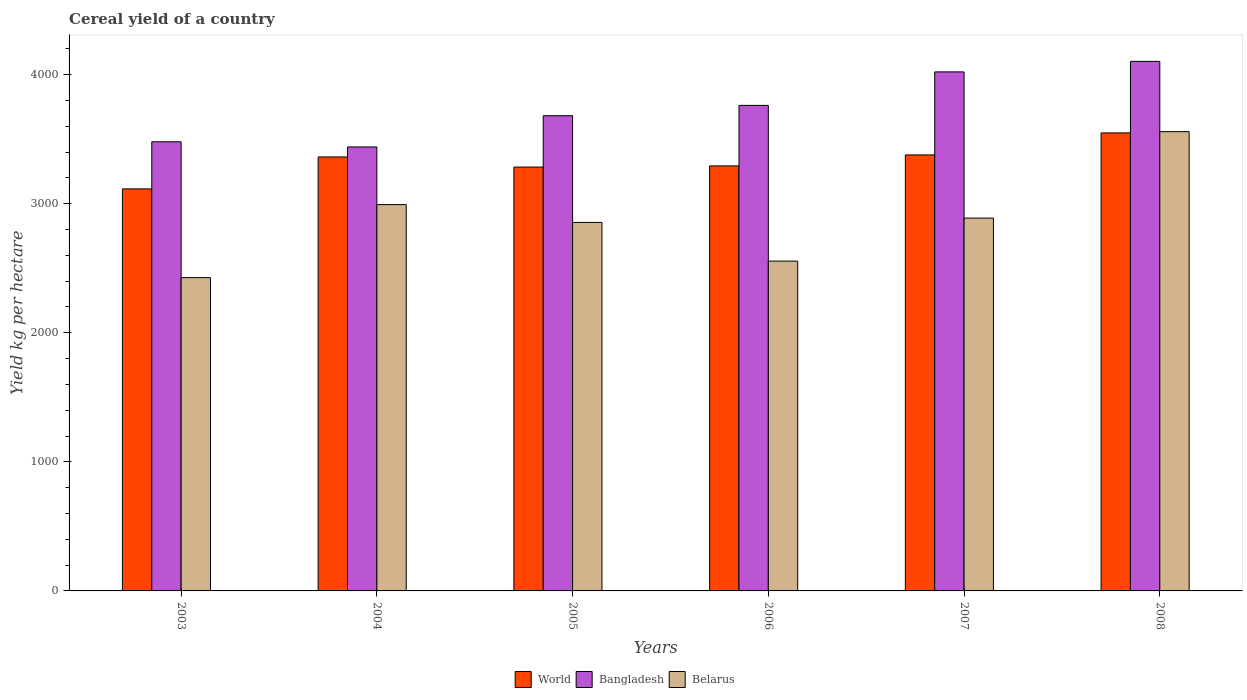How many different coloured bars are there?
Provide a short and direct response. 3. How many groups of bars are there?
Ensure brevity in your answer.  6. Are the number of bars per tick equal to the number of legend labels?
Your answer should be compact. Yes. How many bars are there on the 2nd tick from the left?
Make the answer very short. 3. How many bars are there on the 4th tick from the right?
Provide a short and direct response. 3. In how many cases, is the number of bars for a given year not equal to the number of legend labels?
Your answer should be very brief. 0. What is the total cereal yield in Bangladesh in 2006?
Your answer should be very brief. 3761.37. Across all years, what is the maximum total cereal yield in World?
Make the answer very short. 3548.21. Across all years, what is the minimum total cereal yield in Bangladesh?
Ensure brevity in your answer.  3439.43. In which year was the total cereal yield in Bangladesh minimum?
Keep it short and to the point. 2004. What is the total total cereal yield in Belarus in the graph?
Provide a succinct answer. 1.73e+04. What is the difference between the total cereal yield in Belarus in 2005 and that in 2006?
Provide a short and direct response. 299.7. What is the difference between the total cereal yield in Bangladesh in 2007 and the total cereal yield in World in 2006?
Provide a short and direct response. 728.34. What is the average total cereal yield in Belarus per year?
Make the answer very short. 2879.32. In the year 2005, what is the difference between the total cereal yield in Bangladesh and total cereal yield in World?
Provide a succinct answer. 398.08. In how many years, is the total cereal yield in Belarus greater than 2600 kg per hectare?
Provide a short and direct response. 4. What is the ratio of the total cereal yield in Bangladesh in 2003 to that in 2005?
Make the answer very short. 0.95. What is the difference between the highest and the second highest total cereal yield in Belarus?
Provide a succinct answer. 565.25. What is the difference between the highest and the lowest total cereal yield in Bangladesh?
Your response must be concise. 663.11. What does the 3rd bar from the left in 2005 represents?
Offer a terse response. Belarus. What does the 1st bar from the right in 2003 represents?
Make the answer very short. Belarus. Are all the bars in the graph horizontal?
Your response must be concise. No. How many years are there in the graph?
Ensure brevity in your answer.  6. What is the difference between two consecutive major ticks on the Y-axis?
Your answer should be very brief. 1000. Does the graph contain any zero values?
Give a very brief answer. No. Where does the legend appear in the graph?
Provide a succinct answer. Bottom center. How many legend labels are there?
Your answer should be very brief. 3. What is the title of the graph?
Keep it short and to the point. Cereal yield of a country. Does "French Polynesia" appear as one of the legend labels in the graph?
Provide a succinct answer. No. What is the label or title of the Y-axis?
Your answer should be very brief. Yield kg per hectare. What is the Yield kg per hectare in World in 2003?
Your response must be concise. 3114.57. What is the Yield kg per hectare in Bangladesh in 2003?
Ensure brevity in your answer.  3479.32. What is the Yield kg per hectare in Belarus in 2003?
Ensure brevity in your answer.  2427.03. What is the Yield kg per hectare of World in 2004?
Provide a short and direct response. 3362.03. What is the Yield kg per hectare of Bangladesh in 2004?
Give a very brief answer. 3439.43. What is the Yield kg per hectare of Belarus in 2004?
Your answer should be compact. 2992.76. What is the Yield kg per hectare in World in 2005?
Keep it short and to the point. 3283.52. What is the Yield kg per hectare of Bangladesh in 2005?
Provide a short and direct response. 3681.6. What is the Yield kg per hectare in Belarus in 2005?
Keep it short and to the point. 2854.8. What is the Yield kg per hectare in World in 2006?
Offer a terse response. 3292.55. What is the Yield kg per hectare of Bangladesh in 2006?
Your response must be concise. 3761.37. What is the Yield kg per hectare in Belarus in 2006?
Provide a succinct answer. 2555.11. What is the Yield kg per hectare of World in 2007?
Your answer should be compact. 3377.69. What is the Yield kg per hectare of Bangladesh in 2007?
Offer a terse response. 4020.89. What is the Yield kg per hectare of Belarus in 2007?
Offer a terse response. 2888.18. What is the Yield kg per hectare in World in 2008?
Give a very brief answer. 3548.21. What is the Yield kg per hectare in Bangladesh in 2008?
Give a very brief answer. 4102.54. What is the Yield kg per hectare in Belarus in 2008?
Make the answer very short. 3558.01. Across all years, what is the maximum Yield kg per hectare in World?
Ensure brevity in your answer.  3548.21. Across all years, what is the maximum Yield kg per hectare in Bangladesh?
Offer a terse response. 4102.54. Across all years, what is the maximum Yield kg per hectare in Belarus?
Offer a terse response. 3558.01. Across all years, what is the minimum Yield kg per hectare of World?
Provide a succinct answer. 3114.57. Across all years, what is the minimum Yield kg per hectare of Bangladesh?
Make the answer very short. 3439.43. Across all years, what is the minimum Yield kg per hectare of Belarus?
Your response must be concise. 2427.03. What is the total Yield kg per hectare in World in the graph?
Make the answer very short. 2.00e+04. What is the total Yield kg per hectare of Bangladesh in the graph?
Your answer should be very brief. 2.25e+04. What is the total Yield kg per hectare of Belarus in the graph?
Offer a very short reply. 1.73e+04. What is the difference between the Yield kg per hectare of World in 2003 and that in 2004?
Give a very brief answer. -247.46. What is the difference between the Yield kg per hectare in Bangladesh in 2003 and that in 2004?
Your answer should be very brief. 39.88. What is the difference between the Yield kg per hectare of Belarus in 2003 and that in 2004?
Offer a very short reply. -565.73. What is the difference between the Yield kg per hectare in World in 2003 and that in 2005?
Your answer should be very brief. -168.95. What is the difference between the Yield kg per hectare in Bangladesh in 2003 and that in 2005?
Your answer should be very brief. -202.28. What is the difference between the Yield kg per hectare of Belarus in 2003 and that in 2005?
Your answer should be compact. -427.77. What is the difference between the Yield kg per hectare in World in 2003 and that in 2006?
Provide a short and direct response. -177.98. What is the difference between the Yield kg per hectare in Bangladesh in 2003 and that in 2006?
Offer a very short reply. -282.05. What is the difference between the Yield kg per hectare of Belarus in 2003 and that in 2006?
Ensure brevity in your answer.  -128.08. What is the difference between the Yield kg per hectare in World in 2003 and that in 2007?
Offer a terse response. -263.13. What is the difference between the Yield kg per hectare of Bangladesh in 2003 and that in 2007?
Offer a terse response. -541.57. What is the difference between the Yield kg per hectare in Belarus in 2003 and that in 2007?
Your response must be concise. -461.15. What is the difference between the Yield kg per hectare of World in 2003 and that in 2008?
Give a very brief answer. -433.64. What is the difference between the Yield kg per hectare of Bangladesh in 2003 and that in 2008?
Offer a very short reply. -623.22. What is the difference between the Yield kg per hectare in Belarus in 2003 and that in 2008?
Your response must be concise. -1130.98. What is the difference between the Yield kg per hectare in World in 2004 and that in 2005?
Give a very brief answer. 78.51. What is the difference between the Yield kg per hectare in Bangladesh in 2004 and that in 2005?
Your answer should be compact. -242.16. What is the difference between the Yield kg per hectare of Belarus in 2004 and that in 2005?
Give a very brief answer. 137.95. What is the difference between the Yield kg per hectare in World in 2004 and that in 2006?
Your answer should be very brief. 69.47. What is the difference between the Yield kg per hectare in Bangladesh in 2004 and that in 2006?
Your response must be concise. -321.93. What is the difference between the Yield kg per hectare in Belarus in 2004 and that in 2006?
Your answer should be very brief. 437.65. What is the difference between the Yield kg per hectare of World in 2004 and that in 2007?
Your answer should be very brief. -15.67. What is the difference between the Yield kg per hectare in Bangladesh in 2004 and that in 2007?
Give a very brief answer. -581.46. What is the difference between the Yield kg per hectare in Belarus in 2004 and that in 2007?
Offer a terse response. 104.58. What is the difference between the Yield kg per hectare in World in 2004 and that in 2008?
Ensure brevity in your answer.  -186.18. What is the difference between the Yield kg per hectare in Bangladesh in 2004 and that in 2008?
Provide a succinct answer. -663.11. What is the difference between the Yield kg per hectare in Belarus in 2004 and that in 2008?
Keep it short and to the point. -565.25. What is the difference between the Yield kg per hectare in World in 2005 and that in 2006?
Your response must be concise. -9.04. What is the difference between the Yield kg per hectare in Bangladesh in 2005 and that in 2006?
Your response must be concise. -79.77. What is the difference between the Yield kg per hectare of Belarus in 2005 and that in 2006?
Offer a terse response. 299.7. What is the difference between the Yield kg per hectare in World in 2005 and that in 2007?
Offer a terse response. -94.18. What is the difference between the Yield kg per hectare of Bangladesh in 2005 and that in 2007?
Make the answer very short. -339.29. What is the difference between the Yield kg per hectare in Belarus in 2005 and that in 2007?
Your response must be concise. -33.38. What is the difference between the Yield kg per hectare of World in 2005 and that in 2008?
Make the answer very short. -264.69. What is the difference between the Yield kg per hectare in Bangladesh in 2005 and that in 2008?
Your answer should be compact. -420.94. What is the difference between the Yield kg per hectare of Belarus in 2005 and that in 2008?
Keep it short and to the point. -703.2. What is the difference between the Yield kg per hectare of World in 2006 and that in 2007?
Keep it short and to the point. -85.14. What is the difference between the Yield kg per hectare of Bangladesh in 2006 and that in 2007?
Make the answer very short. -259.52. What is the difference between the Yield kg per hectare in Belarus in 2006 and that in 2007?
Your response must be concise. -333.07. What is the difference between the Yield kg per hectare in World in 2006 and that in 2008?
Make the answer very short. -255.66. What is the difference between the Yield kg per hectare of Bangladesh in 2006 and that in 2008?
Your answer should be very brief. -341.17. What is the difference between the Yield kg per hectare of Belarus in 2006 and that in 2008?
Provide a succinct answer. -1002.9. What is the difference between the Yield kg per hectare in World in 2007 and that in 2008?
Make the answer very short. -170.51. What is the difference between the Yield kg per hectare in Bangladesh in 2007 and that in 2008?
Make the answer very short. -81.65. What is the difference between the Yield kg per hectare of Belarus in 2007 and that in 2008?
Make the answer very short. -669.83. What is the difference between the Yield kg per hectare in World in 2003 and the Yield kg per hectare in Bangladesh in 2004?
Ensure brevity in your answer.  -324.87. What is the difference between the Yield kg per hectare of World in 2003 and the Yield kg per hectare of Belarus in 2004?
Give a very brief answer. 121.81. What is the difference between the Yield kg per hectare of Bangladesh in 2003 and the Yield kg per hectare of Belarus in 2004?
Your answer should be compact. 486.56. What is the difference between the Yield kg per hectare in World in 2003 and the Yield kg per hectare in Bangladesh in 2005?
Offer a very short reply. -567.03. What is the difference between the Yield kg per hectare of World in 2003 and the Yield kg per hectare of Belarus in 2005?
Give a very brief answer. 259.76. What is the difference between the Yield kg per hectare of Bangladesh in 2003 and the Yield kg per hectare of Belarus in 2005?
Offer a terse response. 624.51. What is the difference between the Yield kg per hectare in World in 2003 and the Yield kg per hectare in Bangladesh in 2006?
Your response must be concise. -646.8. What is the difference between the Yield kg per hectare in World in 2003 and the Yield kg per hectare in Belarus in 2006?
Offer a terse response. 559.46. What is the difference between the Yield kg per hectare of Bangladesh in 2003 and the Yield kg per hectare of Belarus in 2006?
Offer a terse response. 924.21. What is the difference between the Yield kg per hectare in World in 2003 and the Yield kg per hectare in Bangladesh in 2007?
Provide a short and direct response. -906.32. What is the difference between the Yield kg per hectare of World in 2003 and the Yield kg per hectare of Belarus in 2007?
Keep it short and to the point. 226.39. What is the difference between the Yield kg per hectare in Bangladesh in 2003 and the Yield kg per hectare in Belarus in 2007?
Make the answer very short. 591.13. What is the difference between the Yield kg per hectare in World in 2003 and the Yield kg per hectare in Bangladesh in 2008?
Provide a succinct answer. -987.97. What is the difference between the Yield kg per hectare in World in 2003 and the Yield kg per hectare in Belarus in 2008?
Make the answer very short. -443.44. What is the difference between the Yield kg per hectare of Bangladesh in 2003 and the Yield kg per hectare of Belarus in 2008?
Offer a very short reply. -78.69. What is the difference between the Yield kg per hectare in World in 2004 and the Yield kg per hectare in Bangladesh in 2005?
Provide a short and direct response. -319.57. What is the difference between the Yield kg per hectare in World in 2004 and the Yield kg per hectare in Belarus in 2005?
Make the answer very short. 507.22. What is the difference between the Yield kg per hectare of Bangladesh in 2004 and the Yield kg per hectare of Belarus in 2005?
Offer a very short reply. 584.63. What is the difference between the Yield kg per hectare in World in 2004 and the Yield kg per hectare in Bangladesh in 2006?
Provide a short and direct response. -399.34. What is the difference between the Yield kg per hectare of World in 2004 and the Yield kg per hectare of Belarus in 2006?
Make the answer very short. 806.92. What is the difference between the Yield kg per hectare of Bangladesh in 2004 and the Yield kg per hectare of Belarus in 2006?
Offer a terse response. 884.33. What is the difference between the Yield kg per hectare in World in 2004 and the Yield kg per hectare in Bangladesh in 2007?
Keep it short and to the point. -658.86. What is the difference between the Yield kg per hectare in World in 2004 and the Yield kg per hectare in Belarus in 2007?
Give a very brief answer. 473.85. What is the difference between the Yield kg per hectare in Bangladesh in 2004 and the Yield kg per hectare in Belarus in 2007?
Keep it short and to the point. 551.25. What is the difference between the Yield kg per hectare in World in 2004 and the Yield kg per hectare in Bangladesh in 2008?
Your answer should be very brief. -740.51. What is the difference between the Yield kg per hectare of World in 2004 and the Yield kg per hectare of Belarus in 2008?
Keep it short and to the point. -195.98. What is the difference between the Yield kg per hectare of Bangladesh in 2004 and the Yield kg per hectare of Belarus in 2008?
Offer a terse response. -118.58. What is the difference between the Yield kg per hectare in World in 2005 and the Yield kg per hectare in Bangladesh in 2006?
Make the answer very short. -477.85. What is the difference between the Yield kg per hectare in World in 2005 and the Yield kg per hectare in Belarus in 2006?
Give a very brief answer. 728.41. What is the difference between the Yield kg per hectare in Bangladesh in 2005 and the Yield kg per hectare in Belarus in 2006?
Provide a short and direct response. 1126.49. What is the difference between the Yield kg per hectare in World in 2005 and the Yield kg per hectare in Bangladesh in 2007?
Make the answer very short. -737.37. What is the difference between the Yield kg per hectare of World in 2005 and the Yield kg per hectare of Belarus in 2007?
Provide a succinct answer. 395.33. What is the difference between the Yield kg per hectare of Bangladesh in 2005 and the Yield kg per hectare of Belarus in 2007?
Make the answer very short. 793.41. What is the difference between the Yield kg per hectare in World in 2005 and the Yield kg per hectare in Bangladesh in 2008?
Make the answer very short. -819.02. What is the difference between the Yield kg per hectare in World in 2005 and the Yield kg per hectare in Belarus in 2008?
Keep it short and to the point. -274.49. What is the difference between the Yield kg per hectare of Bangladesh in 2005 and the Yield kg per hectare of Belarus in 2008?
Provide a short and direct response. 123.59. What is the difference between the Yield kg per hectare in World in 2006 and the Yield kg per hectare in Bangladesh in 2007?
Offer a very short reply. -728.34. What is the difference between the Yield kg per hectare in World in 2006 and the Yield kg per hectare in Belarus in 2007?
Provide a succinct answer. 404.37. What is the difference between the Yield kg per hectare of Bangladesh in 2006 and the Yield kg per hectare of Belarus in 2007?
Provide a short and direct response. 873.19. What is the difference between the Yield kg per hectare of World in 2006 and the Yield kg per hectare of Bangladesh in 2008?
Make the answer very short. -809.99. What is the difference between the Yield kg per hectare in World in 2006 and the Yield kg per hectare in Belarus in 2008?
Keep it short and to the point. -265.46. What is the difference between the Yield kg per hectare in Bangladesh in 2006 and the Yield kg per hectare in Belarus in 2008?
Offer a very short reply. 203.36. What is the difference between the Yield kg per hectare of World in 2007 and the Yield kg per hectare of Bangladesh in 2008?
Your answer should be compact. -724.84. What is the difference between the Yield kg per hectare of World in 2007 and the Yield kg per hectare of Belarus in 2008?
Keep it short and to the point. -180.31. What is the difference between the Yield kg per hectare in Bangladesh in 2007 and the Yield kg per hectare in Belarus in 2008?
Your answer should be very brief. 462.88. What is the average Yield kg per hectare of World per year?
Your answer should be very brief. 3329.76. What is the average Yield kg per hectare of Bangladesh per year?
Ensure brevity in your answer.  3747.52. What is the average Yield kg per hectare of Belarus per year?
Give a very brief answer. 2879.32. In the year 2003, what is the difference between the Yield kg per hectare of World and Yield kg per hectare of Bangladesh?
Provide a succinct answer. -364.75. In the year 2003, what is the difference between the Yield kg per hectare in World and Yield kg per hectare in Belarus?
Give a very brief answer. 687.54. In the year 2003, what is the difference between the Yield kg per hectare of Bangladesh and Yield kg per hectare of Belarus?
Your answer should be very brief. 1052.28. In the year 2004, what is the difference between the Yield kg per hectare in World and Yield kg per hectare in Bangladesh?
Your response must be concise. -77.41. In the year 2004, what is the difference between the Yield kg per hectare of World and Yield kg per hectare of Belarus?
Provide a short and direct response. 369.27. In the year 2004, what is the difference between the Yield kg per hectare in Bangladesh and Yield kg per hectare in Belarus?
Your answer should be very brief. 446.68. In the year 2005, what is the difference between the Yield kg per hectare in World and Yield kg per hectare in Bangladesh?
Offer a terse response. -398.08. In the year 2005, what is the difference between the Yield kg per hectare of World and Yield kg per hectare of Belarus?
Your response must be concise. 428.71. In the year 2005, what is the difference between the Yield kg per hectare in Bangladesh and Yield kg per hectare in Belarus?
Keep it short and to the point. 826.79. In the year 2006, what is the difference between the Yield kg per hectare in World and Yield kg per hectare in Bangladesh?
Provide a succinct answer. -468.82. In the year 2006, what is the difference between the Yield kg per hectare in World and Yield kg per hectare in Belarus?
Give a very brief answer. 737.44. In the year 2006, what is the difference between the Yield kg per hectare in Bangladesh and Yield kg per hectare in Belarus?
Keep it short and to the point. 1206.26. In the year 2007, what is the difference between the Yield kg per hectare in World and Yield kg per hectare in Bangladesh?
Offer a terse response. -643.19. In the year 2007, what is the difference between the Yield kg per hectare in World and Yield kg per hectare in Belarus?
Give a very brief answer. 489.51. In the year 2007, what is the difference between the Yield kg per hectare in Bangladesh and Yield kg per hectare in Belarus?
Give a very brief answer. 1132.71. In the year 2008, what is the difference between the Yield kg per hectare of World and Yield kg per hectare of Bangladesh?
Make the answer very short. -554.33. In the year 2008, what is the difference between the Yield kg per hectare of World and Yield kg per hectare of Belarus?
Make the answer very short. -9.8. In the year 2008, what is the difference between the Yield kg per hectare of Bangladesh and Yield kg per hectare of Belarus?
Provide a short and direct response. 544.53. What is the ratio of the Yield kg per hectare of World in 2003 to that in 2004?
Keep it short and to the point. 0.93. What is the ratio of the Yield kg per hectare of Bangladesh in 2003 to that in 2004?
Your answer should be compact. 1.01. What is the ratio of the Yield kg per hectare of Belarus in 2003 to that in 2004?
Provide a short and direct response. 0.81. What is the ratio of the Yield kg per hectare of World in 2003 to that in 2005?
Your answer should be very brief. 0.95. What is the ratio of the Yield kg per hectare of Bangladesh in 2003 to that in 2005?
Your response must be concise. 0.95. What is the ratio of the Yield kg per hectare in Belarus in 2003 to that in 2005?
Your answer should be compact. 0.85. What is the ratio of the Yield kg per hectare in World in 2003 to that in 2006?
Provide a succinct answer. 0.95. What is the ratio of the Yield kg per hectare of Bangladesh in 2003 to that in 2006?
Your response must be concise. 0.93. What is the ratio of the Yield kg per hectare of Belarus in 2003 to that in 2006?
Give a very brief answer. 0.95. What is the ratio of the Yield kg per hectare of World in 2003 to that in 2007?
Make the answer very short. 0.92. What is the ratio of the Yield kg per hectare of Bangladesh in 2003 to that in 2007?
Your answer should be very brief. 0.87. What is the ratio of the Yield kg per hectare in Belarus in 2003 to that in 2007?
Offer a very short reply. 0.84. What is the ratio of the Yield kg per hectare of World in 2003 to that in 2008?
Provide a short and direct response. 0.88. What is the ratio of the Yield kg per hectare in Bangladesh in 2003 to that in 2008?
Provide a succinct answer. 0.85. What is the ratio of the Yield kg per hectare in Belarus in 2003 to that in 2008?
Ensure brevity in your answer.  0.68. What is the ratio of the Yield kg per hectare of World in 2004 to that in 2005?
Your response must be concise. 1.02. What is the ratio of the Yield kg per hectare of Bangladesh in 2004 to that in 2005?
Offer a very short reply. 0.93. What is the ratio of the Yield kg per hectare in Belarus in 2004 to that in 2005?
Offer a very short reply. 1.05. What is the ratio of the Yield kg per hectare in World in 2004 to that in 2006?
Give a very brief answer. 1.02. What is the ratio of the Yield kg per hectare in Bangladesh in 2004 to that in 2006?
Your response must be concise. 0.91. What is the ratio of the Yield kg per hectare in Belarus in 2004 to that in 2006?
Make the answer very short. 1.17. What is the ratio of the Yield kg per hectare of World in 2004 to that in 2007?
Your answer should be compact. 1. What is the ratio of the Yield kg per hectare of Bangladesh in 2004 to that in 2007?
Keep it short and to the point. 0.86. What is the ratio of the Yield kg per hectare of Belarus in 2004 to that in 2007?
Your answer should be compact. 1.04. What is the ratio of the Yield kg per hectare in World in 2004 to that in 2008?
Your answer should be very brief. 0.95. What is the ratio of the Yield kg per hectare of Bangladesh in 2004 to that in 2008?
Offer a very short reply. 0.84. What is the ratio of the Yield kg per hectare in Belarus in 2004 to that in 2008?
Your response must be concise. 0.84. What is the ratio of the Yield kg per hectare of Bangladesh in 2005 to that in 2006?
Offer a terse response. 0.98. What is the ratio of the Yield kg per hectare in Belarus in 2005 to that in 2006?
Provide a short and direct response. 1.12. What is the ratio of the Yield kg per hectare in World in 2005 to that in 2007?
Provide a short and direct response. 0.97. What is the ratio of the Yield kg per hectare in Bangladesh in 2005 to that in 2007?
Provide a succinct answer. 0.92. What is the ratio of the Yield kg per hectare of Belarus in 2005 to that in 2007?
Your answer should be compact. 0.99. What is the ratio of the Yield kg per hectare of World in 2005 to that in 2008?
Your response must be concise. 0.93. What is the ratio of the Yield kg per hectare of Bangladesh in 2005 to that in 2008?
Provide a succinct answer. 0.9. What is the ratio of the Yield kg per hectare of Belarus in 2005 to that in 2008?
Give a very brief answer. 0.8. What is the ratio of the Yield kg per hectare in World in 2006 to that in 2007?
Keep it short and to the point. 0.97. What is the ratio of the Yield kg per hectare of Bangladesh in 2006 to that in 2007?
Make the answer very short. 0.94. What is the ratio of the Yield kg per hectare in Belarus in 2006 to that in 2007?
Your answer should be compact. 0.88. What is the ratio of the Yield kg per hectare in World in 2006 to that in 2008?
Your response must be concise. 0.93. What is the ratio of the Yield kg per hectare of Bangladesh in 2006 to that in 2008?
Provide a short and direct response. 0.92. What is the ratio of the Yield kg per hectare in Belarus in 2006 to that in 2008?
Make the answer very short. 0.72. What is the ratio of the Yield kg per hectare in World in 2007 to that in 2008?
Offer a very short reply. 0.95. What is the ratio of the Yield kg per hectare of Bangladesh in 2007 to that in 2008?
Make the answer very short. 0.98. What is the ratio of the Yield kg per hectare in Belarus in 2007 to that in 2008?
Your answer should be very brief. 0.81. What is the difference between the highest and the second highest Yield kg per hectare of World?
Keep it short and to the point. 170.51. What is the difference between the highest and the second highest Yield kg per hectare of Bangladesh?
Offer a terse response. 81.65. What is the difference between the highest and the second highest Yield kg per hectare of Belarus?
Give a very brief answer. 565.25. What is the difference between the highest and the lowest Yield kg per hectare of World?
Your answer should be compact. 433.64. What is the difference between the highest and the lowest Yield kg per hectare of Bangladesh?
Provide a succinct answer. 663.11. What is the difference between the highest and the lowest Yield kg per hectare in Belarus?
Make the answer very short. 1130.98. 